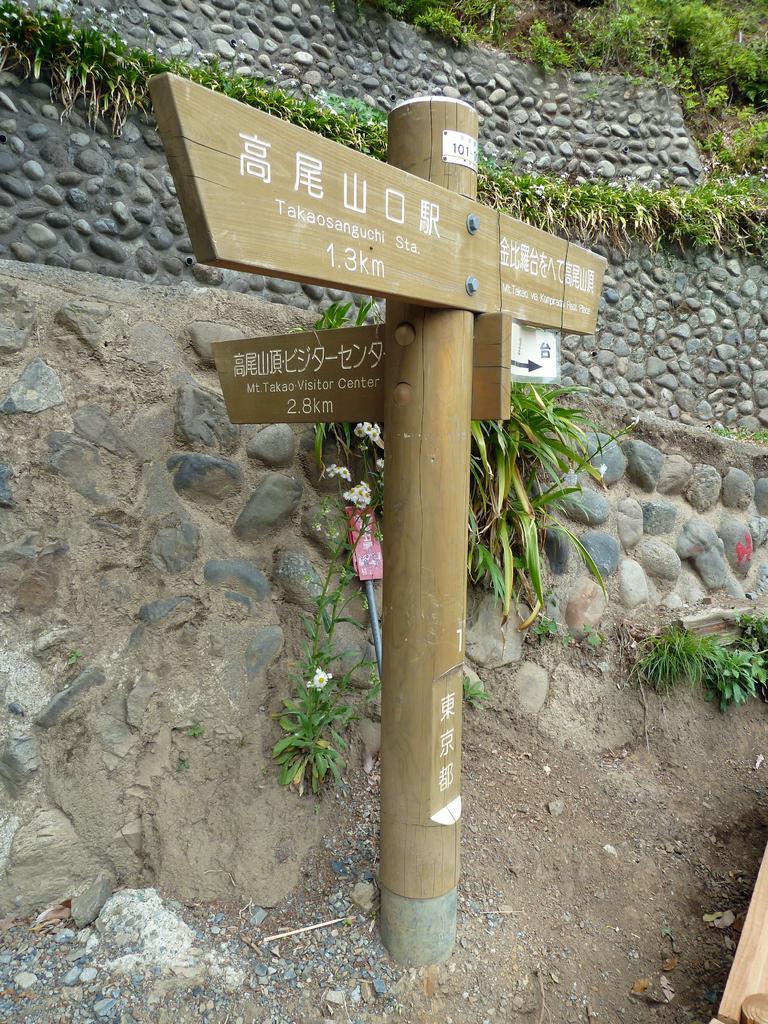Please provide a concise description of this image. In this image we can see a sign board to a pole. We can also see some plants and a wall built with stones. 